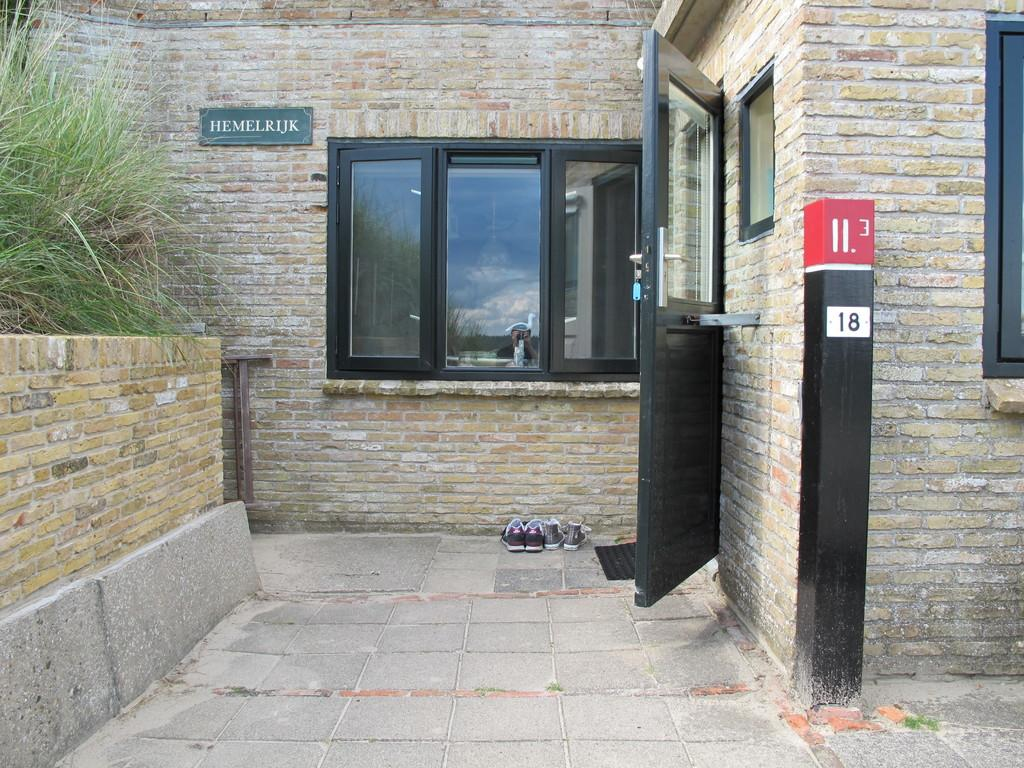What type of structure is visible in the image? There is a building in the image. What features can be seen on the building? The building has windows and a door. What object is present near the building? There is a pole in the image. What object is placed outside the building? There is a mat in the image. What items are related to footwear in the image? There are shoes in the image. What sign is visible in the image? There is a name board in the image. What type of vegetation is present in the image? There is grass in the image. What architectural element is visible in the image? There is a wall in the image. What can be seen in the reflection of the image? There is a reflection of a person and the sky in the image. Where is the mine located in the image? There is no mine present in the image. What type of hydrant is visible in the image? There is no hydrant present in the image. 